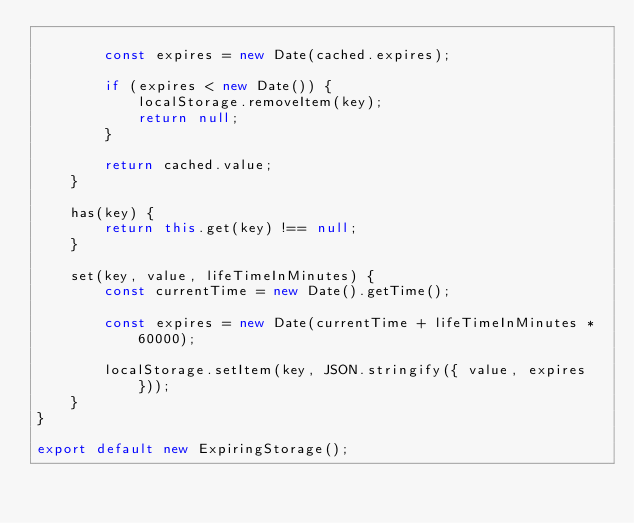Convert code to text. <code><loc_0><loc_0><loc_500><loc_500><_JavaScript_>
        const expires = new Date(cached.expires);

        if (expires < new Date()) {
            localStorage.removeItem(key);
            return null;
        }

        return cached.value;
    }

    has(key) {
        return this.get(key) !== null;
    }

    set(key, value, lifeTimeInMinutes) {
        const currentTime = new Date().getTime();

        const expires = new Date(currentTime + lifeTimeInMinutes * 60000);

        localStorage.setItem(key, JSON.stringify({ value, expires }));
    }
}

export default new ExpiringStorage();
</code> 